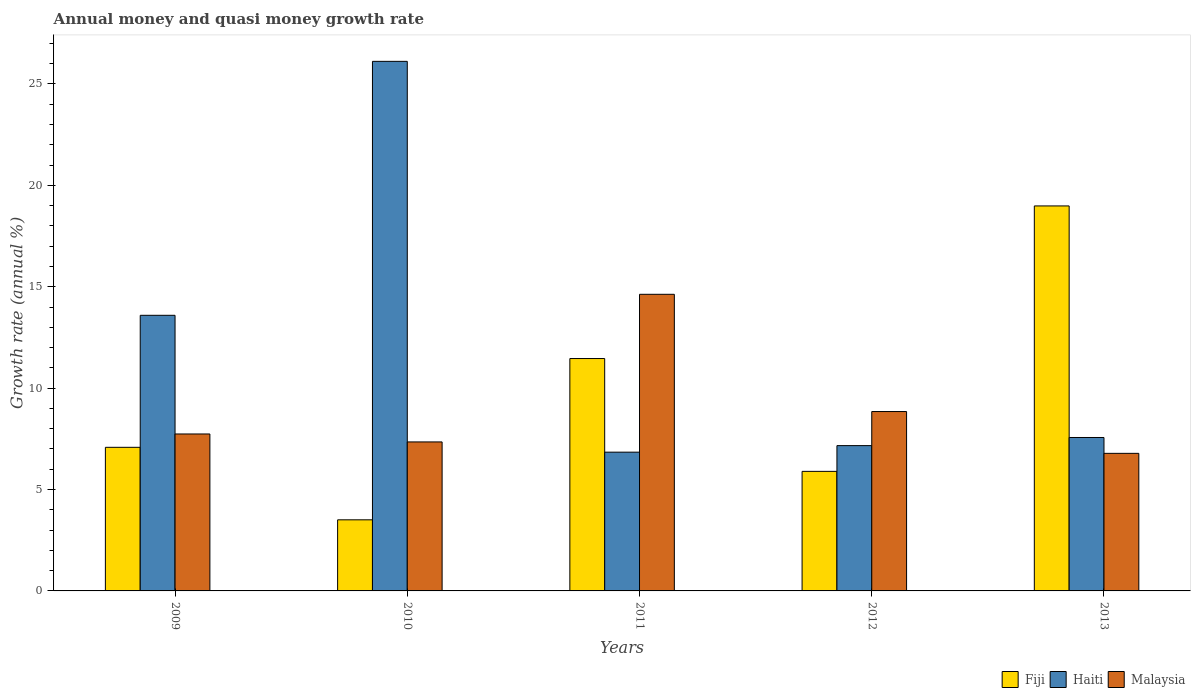How many different coloured bars are there?
Your answer should be compact. 3. Are the number of bars per tick equal to the number of legend labels?
Your answer should be very brief. Yes. Are the number of bars on each tick of the X-axis equal?
Provide a succinct answer. Yes. What is the label of the 5th group of bars from the left?
Provide a short and direct response. 2013. In how many cases, is the number of bars for a given year not equal to the number of legend labels?
Your answer should be very brief. 0. What is the growth rate in Haiti in 2011?
Provide a succinct answer. 6.84. Across all years, what is the maximum growth rate in Fiji?
Your answer should be compact. 18.99. Across all years, what is the minimum growth rate in Malaysia?
Offer a terse response. 6.78. In which year was the growth rate in Fiji maximum?
Keep it short and to the point. 2013. What is the total growth rate in Haiti in the graph?
Offer a very short reply. 61.28. What is the difference between the growth rate in Haiti in 2009 and that in 2010?
Give a very brief answer. -12.52. What is the difference between the growth rate in Fiji in 2010 and the growth rate in Haiti in 2012?
Make the answer very short. -3.66. What is the average growth rate in Haiti per year?
Your response must be concise. 12.26. In the year 2009, what is the difference between the growth rate in Haiti and growth rate in Fiji?
Ensure brevity in your answer.  6.51. What is the ratio of the growth rate in Haiti in 2012 to that in 2013?
Your response must be concise. 0.95. Is the growth rate in Fiji in 2012 less than that in 2013?
Your answer should be compact. Yes. What is the difference between the highest and the second highest growth rate in Malaysia?
Your answer should be very brief. 5.78. What is the difference between the highest and the lowest growth rate in Malaysia?
Your response must be concise. 7.84. In how many years, is the growth rate in Malaysia greater than the average growth rate in Malaysia taken over all years?
Give a very brief answer. 1. Is the sum of the growth rate in Fiji in 2011 and 2013 greater than the maximum growth rate in Malaysia across all years?
Your answer should be compact. Yes. What does the 1st bar from the left in 2010 represents?
Provide a succinct answer. Fiji. What does the 2nd bar from the right in 2011 represents?
Provide a succinct answer. Haiti. How many years are there in the graph?
Give a very brief answer. 5. What is the difference between two consecutive major ticks on the Y-axis?
Keep it short and to the point. 5. Does the graph contain any zero values?
Ensure brevity in your answer.  No. How are the legend labels stacked?
Give a very brief answer. Horizontal. What is the title of the graph?
Ensure brevity in your answer.  Annual money and quasi money growth rate. Does "Small states" appear as one of the legend labels in the graph?
Offer a terse response. No. What is the label or title of the Y-axis?
Provide a succinct answer. Growth rate (annual %). What is the Growth rate (annual %) of Fiji in 2009?
Your answer should be very brief. 7.08. What is the Growth rate (annual %) in Haiti in 2009?
Provide a short and direct response. 13.59. What is the Growth rate (annual %) in Malaysia in 2009?
Give a very brief answer. 7.74. What is the Growth rate (annual %) of Fiji in 2010?
Provide a short and direct response. 3.51. What is the Growth rate (annual %) of Haiti in 2010?
Provide a succinct answer. 26.12. What is the Growth rate (annual %) of Malaysia in 2010?
Keep it short and to the point. 7.35. What is the Growth rate (annual %) of Fiji in 2011?
Ensure brevity in your answer.  11.46. What is the Growth rate (annual %) of Haiti in 2011?
Offer a very short reply. 6.84. What is the Growth rate (annual %) of Malaysia in 2011?
Provide a short and direct response. 14.63. What is the Growth rate (annual %) of Fiji in 2012?
Your answer should be very brief. 5.9. What is the Growth rate (annual %) in Haiti in 2012?
Your answer should be compact. 7.17. What is the Growth rate (annual %) of Malaysia in 2012?
Provide a succinct answer. 8.85. What is the Growth rate (annual %) in Fiji in 2013?
Give a very brief answer. 18.99. What is the Growth rate (annual %) of Haiti in 2013?
Provide a succinct answer. 7.57. What is the Growth rate (annual %) in Malaysia in 2013?
Keep it short and to the point. 6.78. Across all years, what is the maximum Growth rate (annual %) in Fiji?
Give a very brief answer. 18.99. Across all years, what is the maximum Growth rate (annual %) of Haiti?
Make the answer very short. 26.12. Across all years, what is the maximum Growth rate (annual %) of Malaysia?
Your answer should be compact. 14.63. Across all years, what is the minimum Growth rate (annual %) in Fiji?
Your answer should be compact. 3.51. Across all years, what is the minimum Growth rate (annual %) in Haiti?
Your answer should be very brief. 6.84. Across all years, what is the minimum Growth rate (annual %) of Malaysia?
Your response must be concise. 6.78. What is the total Growth rate (annual %) in Fiji in the graph?
Offer a very short reply. 46.93. What is the total Growth rate (annual %) of Haiti in the graph?
Make the answer very short. 61.28. What is the total Growth rate (annual %) of Malaysia in the graph?
Provide a succinct answer. 45.35. What is the difference between the Growth rate (annual %) in Fiji in 2009 and that in 2010?
Your answer should be compact. 3.58. What is the difference between the Growth rate (annual %) of Haiti in 2009 and that in 2010?
Your answer should be compact. -12.52. What is the difference between the Growth rate (annual %) in Malaysia in 2009 and that in 2010?
Your response must be concise. 0.39. What is the difference between the Growth rate (annual %) in Fiji in 2009 and that in 2011?
Provide a short and direct response. -4.38. What is the difference between the Growth rate (annual %) in Haiti in 2009 and that in 2011?
Provide a short and direct response. 6.75. What is the difference between the Growth rate (annual %) in Malaysia in 2009 and that in 2011?
Your response must be concise. -6.89. What is the difference between the Growth rate (annual %) of Fiji in 2009 and that in 2012?
Make the answer very short. 1.19. What is the difference between the Growth rate (annual %) in Haiti in 2009 and that in 2012?
Provide a short and direct response. 6.43. What is the difference between the Growth rate (annual %) in Malaysia in 2009 and that in 2012?
Offer a very short reply. -1.11. What is the difference between the Growth rate (annual %) in Fiji in 2009 and that in 2013?
Give a very brief answer. -11.9. What is the difference between the Growth rate (annual %) in Haiti in 2009 and that in 2013?
Provide a short and direct response. 6.03. What is the difference between the Growth rate (annual %) of Malaysia in 2009 and that in 2013?
Offer a very short reply. 0.96. What is the difference between the Growth rate (annual %) in Fiji in 2010 and that in 2011?
Provide a succinct answer. -7.95. What is the difference between the Growth rate (annual %) of Haiti in 2010 and that in 2011?
Provide a succinct answer. 19.27. What is the difference between the Growth rate (annual %) of Malaysia in 2010 and that in 2011?
Give a very brief answer. -7.28. What is the difference between the Growth rate (annual %) of Fiji in 2010 and that in 2012?
Offer a terse response. -2.39. What is the difference between the Growth rate (annual %) in Haiti in 2010 and that in 2012?
Keep it short and to the point. 18.95. What is the difference between the Growth rate (annual %) in Malaysia in 2010 and that in 2012?
Offer a very short reply. -1.5. What is the difference between the Growth rate (annual %) of Fiji in 2010 and that in 2013?
Your answer should be very brief. -15.48. What is the difference between the Growth rate (annual %) of Haiti in 2010 and that in 2013?
Keep it short and to the point. 18.55. What is the difference between the Growth rate (annual %) in Malaysia in 2010 and that in 2013?
Offer a very short reply. 0.56. What is the difference between the Growth rate (annual %) of Fiji in 2011 and that in 2012?
Offer a terse response. 5.56. What is the difference between the Growth rate (annual %) in Haiti in 2011 and that in 2012?
Your answer should be very brief. -0.32. What is the difference between the Growth rate (annual %) of Malaysia in 2011 and that in 2012?
Provide a short and direct response. 5.78. What is the difference between the Growth rate (annual %) of Fiji in 2011 and that in 2013?
Your answer should be compact. -7.53. What is the difference between the Growth rate (annual %) of Haiti in 2011 and that in 2013?
Make the answer very short. -0.72. What is the difference between the Growth rate (annual %) in Malaysia in 2011 and that in 2013?
Ensure brevity in your answer.  7.84. What is the difference between the Growth rate (annual %) of Fiji in 2012 and that in 2013?
Your answer should be very brief. -13.09. What is the difference between the Growth rate (annual %) in Haiti in 2012 and that in 2013?
Provide a short and direct response. -0.4. What is the difference between the Growth rate (annual %) of Malaysia in 2012 and that in 2013?
Ensure brevity in your answer.  2.06. What is the difference between the Growth rate (annual %) in Fiji in 2009 and the Growth rate (annual %) in Haiti in 2010?
Give a very brief answer. -19.03. What is the difference between the Growth rate (annual %) in Fiji in 2009 and the Growth rate (annual %) in Malaysia in 2010?
Offer a very short reply. -0.27. What is the difference between the Growth rate (annual %) of Haiti in 2009 and the Growth rate (annual %) of Malaysia in 2010?
Keep it short and to the point. 6.24. What is the difference between the Growth rate (annual %) of Fiji in 2009 and the Growth rate (annual %) of Haiti in 2011?
Your answer should be very brief. 0.24. What is the difference between the Growth rate (annual %) of Fiji in 2009 and the Growth rate (annual %) of Malaysia in 2011?
Offer a terse response. -7.55. What is the difference between the Growth rate (annual %) in Haiti in 2009 and the Growth rate (annual %) in Malaysia in 2011?
Give a very brief answer. -1.04. What is the difference between the Growth rate (annual %) of Fiji in 2009 and the Growth rate (annual %) of Haiti in 2012?
Provide a succinct answer. -0.08. What is the difference between the Growth rate (annual %) of Fiji in 2009 and the Growth rate (annual %) of Malaysia in 2012?
Your answer should be compact. -1.76. What is the difference between the Growth rate (annual %) in Haiti in 2009 and the Growth rate (annual %) in Malaysia in 2012?
Provide a short and direct response. 4.75. What is the difference between the Growth rate (annual %) of Fiji in 2009 and the Growth rate (annual %) of Haiti in 2013?
Provide a succinct answer. -0.48. What is the difference between the Growth rate (annual %) of Fiji in 2009 and the Growth rate (annual %) of Malaysia in 2013?
Your answer should be very brief. 0.3. What is the difference between the Growth rate (annual %) of Haiti in 2009 and the Growth rate (annual %) of Malaysia in 2013?
Ensure brevity in your answer.  6.81. What is the difference between the Growth rate (annual %) of Fiji in 2010 and the Growth rate (annual %) of Haiti in 2011?
Offer a very short reply. -3.34. What is the difference between the Growth rate (annual %) in Fiji in 2010 and the Growth rate (annual %) in Malaysia in 2011?
Provide a succinct answer. -11.12. What is the difference between the Growth rate (annual %) of Haiti in 2010 and the Growth rate (annual %) of Malaysia in 2011?
Offer a terse response. 11.49. What is the difference between the Growth rate (annual %) of Fiji in 2010 and the Growth rate (annual %) of Haiti in 2012?
Offer a terse response. -3.66. What is the difference between the Growth rate (annual %) of Fiji in 2010 and the Growth rate (annual %) of Malaysia in 2012?
Keep it short and to the point. -5.34. What is the difference between the Growth rate (annual %) in Haiti in 2010 and the Growth rate (annual %) in Malaysia in 2012?
Provide a succinct answer. 17.27. What is the difference between the Growth rate (annual %) of Fiji in 2010 and the Growth rate (annual %) of Haiti in 2013?
Ensure brevity in your answer.  -4.06. What is the difference between the Growth rate (annual %) of Fiji in 2010 and the Growth rate (annual %) of Malaysia in 2013?
Provide a short and direct response. -3.28. What is the difference between the Growth rate (annual %) in Haiti in 2010 and the Growth rate (annual %) in Malaysia in 2013?
Make the answer very short. 19.33. What is the difference between the Growth rate (annual %) of Fiji in 2011 and the Growth rate (annual %) of Haiti in 2012?
Keep it short and to the point. 4.29. What is the difference between the Growth rate (annual %) in Fiji in 2011 and the Growth rate (annual %) in Malaysia in 2012?
Provide a short and direct response. 2.61. What is the difference between the Growth rate (annual %) in Haiti in 2011 and the Growth rate (annual %) in Malaysia in 2012?
Your response must be concise. -2. What is the difference between the Growth rate (annual %) of Fiji in 2011 and the Growth rate (annual %) of Haiti in 2013?
Provide a succinct answer. 3.89. What is the difference between the Growth rate (annual %) in Fiji in 2011 and the Growth rate (annual %) in Malaysia in 2013?
Make the answer very short. 4.68. What is the difference between the Growth rate (annual %) of Haiti in 2011 and the Growth rate (annual %) of Malaysia in 2013?
Offer a very short reply. 0.06. What is the difference between the Growth rate (annual %) of Fiji in 2012 and the Growth rate (annual %) of Haiti in 2013?
Your answer should be compact. -1.67. What is the difference between the Growth rate (annual %) in Fiji in 2012 and the Growth rate (annual %) in Malaysia in 2013?
Provide a short and direct response. -0.89. What is the difference between the Growth rate (annual %) of Haiti in 2012 and the Growth rate (annual %) of Malaysia in 2013?
Provide a short and direct response. 0.38. What is the average Growth rate (annual %) in Fiji per year?
Provide a succinct answer. 9.39. What is the average Growth rate (annual %) of Haiti per year?
Offer a terse response. 12.26. What is the average Growth rate (annual %) of Malaysia per year?
Your response must be concise. 9.07. In the year 2009, what is the difference between the Growth rate (annual %) of Fiji and Growth rate (annual %) of Haiti?
Provide a short and direct response. -6.51. In the year 2009, what is the difference between the Growth rate (annual %) of Fiji and Growth rate (annual %) of Malaysia?
Ensure brevity in your answer.  -0.66. In the year 2009, what is the difference between the Growth rate (annual %) in Haiti and Growth rate (annual %) in Malaysia?
Your answer should be very brief. 5.85. In the year 2010, what is the difference between the Growth rate (annual %) of Fiji and Growth rate (annual %) of Haiti?
Provide a short and direct response. -22.61. In the year 2010, what is the difference between the Growth rate (annual %) of Fiji and Growth rate (annual %) of Malaysia?
Provide a short and direct response. -3.84. In the year 2010, what is the difference between the Growth rate (annual %) of Haiti and Growth rate (annual %) of Malaysia?
Give a very brief answer. 18.77. In the year 2011, what is the difference between the Growth rate (annual %) of Fiji and Growth rate (annual %) of Haiti?
Your answer should be compact. 4.62. In the year 2011, what is the difference between the Growth rate (annual %) of Fiji and Growth rate (annual %) of Malaysia?
Ensure brevity in your answer.  -3.17. In the year 2011, what is the difference between the Growth rate (annual %) of Haiti and Growth rate (annual %) of Malaysia?
Keep it short and to the point. -7.78. In the year 2012, what is the difference between the Growth rate (annual %) of Fiji and Growth rate (annual %) of Haiti?
Keep it short and to the point. -1.27. In the year 2012, what is the difference between the Growth rate (annual %) in Fiji and Growth rate (annual %) in Malaysia?
Offer a very short reply. -2.95. In the year 2012, what is the difference between the Growth rate (annual %) of Haiti and Growth rate (annual %) of Malaysia?
Provide a succinct answer. -1.68. In the year 2013, what is the difference between the Growth rate (annual %) of Fiji and Growth rate (annual %) of Haiti?
Make the answer very short. 11.42. In the year 2013, what is the difference between the Growth rate (annual %) of Fiji and Growth rate (annual %) of Malaysia?
Your response must be concise. 12.2. In the year 2013, what is the difference between the Growth rate (annual %) in Haiti and Growth rate (annual %) in Malaysia?
Keep it short and to the point. 0.78. What is the ratio of the Growth rate (annual %) of Fiji in 2009 to that in 2010?
Your answer should be very brief. 2.02. What is the ratio of the Growth rate (annual %) in Haiti in 2009 to that in 2010?
Give a very brief answer. 0.52. What is the ratio of the Growth rate (annual %) of Malaysia in 2009 to that in 2010?
Offer a very short reply. 1.05. What is the ratio of the Growth rate (annual %) in Fiji in 2009 to that in 2011?
Provide a succinct answer. 0.62. What is the ratio of the Growth rate (annual %) in Haiti in 2009 to that in 2011?
Provide a short and direct response. 1.99. What is the ratio of the Growth rate (annual %) of Malaysia in 2009 to that in 2011?
Give a very brief answer. 0.53. What is the ratio of the Growth rate (annual %) of Fiji in 2009 to that in 2012?
Offer a very short reply. 1.2. What is the ratio of the Growth rate (annual %) in Haiti in 2009 to that in 2012?
Provide a short and direct response. 1.9. What is the ratio of the Growth rate (annual %) in Fiji in 2009 to that in 2013?
Your answer should be compact. 0.37. What is the ratio of the Growth rate (annual %) of Haiti in 2009 to that in 2013?
Provide a short and direct response. 1.8. What is the ratio of the Growth rate (annual %) in Malaysia in 2009 to that in 2013?
Give a very brief answer. 1.14. What is the ratio of the Growth rate (annual %) of Fiji in 2010 to that in 2011?
Make the answer very short. 0.31. What is the ratio of the Growth rate (annual %) in Haiti in 2010 to that in 2011?
Your answer should be very brief. 3.82. What is the ratio of the Growth rate (annual %) of Malaysia in 2010 to that in 2011?
Provide a short and direct response. 0.5. What is the ratio of the Growth rate (annual %) of Fiji in 2010 to that in 2012?
Ensure brevity in your answer.  0.59. What is the ratio of the Growth rate (annual %) in Haiti in 2010 to that in 2012?
Your response must be concise. 3.64. What is the ratio of the Growth rate (annual %) of Malaysia in 2010 to that in 2012?
Offer a terse response. 0.83. What is the ratio of the Growth rate (annual %) of Fiji in 2010 to that in 2013?
Make the answer very short. 0.18. What is the ratio of the Growth rate (annual %) in Haiti in 2010 to that in 2013?
Provide a short and direct response. 3.45. What is the ratio of the Growth rate (annual %) in Malaysia in 2010 to that in 2013?
Keep it short and to the point. 1.08. What is the ratio of the Growth rate (annual %) in Fiji in 2011 to that in 2012?
Provide a succinct answer. 1.94. What is the ratio of the Growth rate (annual %) in Haiti in 2011 to that in 2012?
Your response must be concise. 0.95. What is the ratio of the Growth rate (annual %) of Malaysia in 2011 to that in 2012?
Provide a short and direct response. 1.65. What is the ratio of the Growth rate (annual %) of Fiji in 2011 to that in 2013?
Ensure brevity in your answer.  0.6. What is the ratio of the Growth rate (annual %) of Haiti in 2011 to that in 2013?
Your answer should be very brief. 0.9. What is the ratio of the Growth rate (annual %) in Malaysia in 2011 to that in 2013?
Your answer should be compact. 2.16. What is the ratio of the Growth rate (annual %) of Fiji in 2012 to that in 2013?
Your answer should be compact. 0.31. What is the ratio of the Growth rate (annual %) in Haiti in 2012 to that in 2013?
Keep it short and to the point. 0.95. What is the ratio of the Growth rate (annual %) of Malaysia in 2012 to that in 2013?
Provide a short and direct response. 1.3. What is the difference between the highest and the second highest Growth rate (annual %) in Fiji?
Offer a terse response. 7.53. What is the difference between the highest and the second highest Growth rate (annual %) of Haiti?
Ensure brevity in your answer.  12.52. What is the difference between the highest and the second highest Growth rate (annual %) of Malaysia?
Offer a very short reply. 5.78. What is the difference between the highest and the lowest Growth rate (annual %) in Fiji?
Your response must be concise. 15.48. What is the difference between the highest and the lowest Growth rate (annual %) in Haiti?
Your response must be concise. 19.27. What is the difference between the highest and the lowest Growth rate (annual %) in Malaysia?
Offer a terse response. 7.84. 